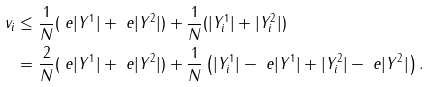<formula> <loc_0><loc_0><loc_500><loc_500>v _ { i } & \leq \frac { 1 } { N } ( \ e | Y ^ { 1 } | + \ e | Y ^ { 2 } | ) + \frac { 1 } { N } ( | Y _ { i } ^ { 1 } | + | Y _ { i } ^ { 2 } | ) \\ & = \frac { 2 } { N } ( \ e | Y ^ { 1 } | + \ e | Y ^ { 2 } | ) + \frac { 1 } { N } \left ( | Y _ { i } ^ { 1 } | - \ e | Y ^ { 1 } | + | Y _ { i } ^ { 2 } | - \ e | Y ^ { 2 } | \right ) .</formula> 